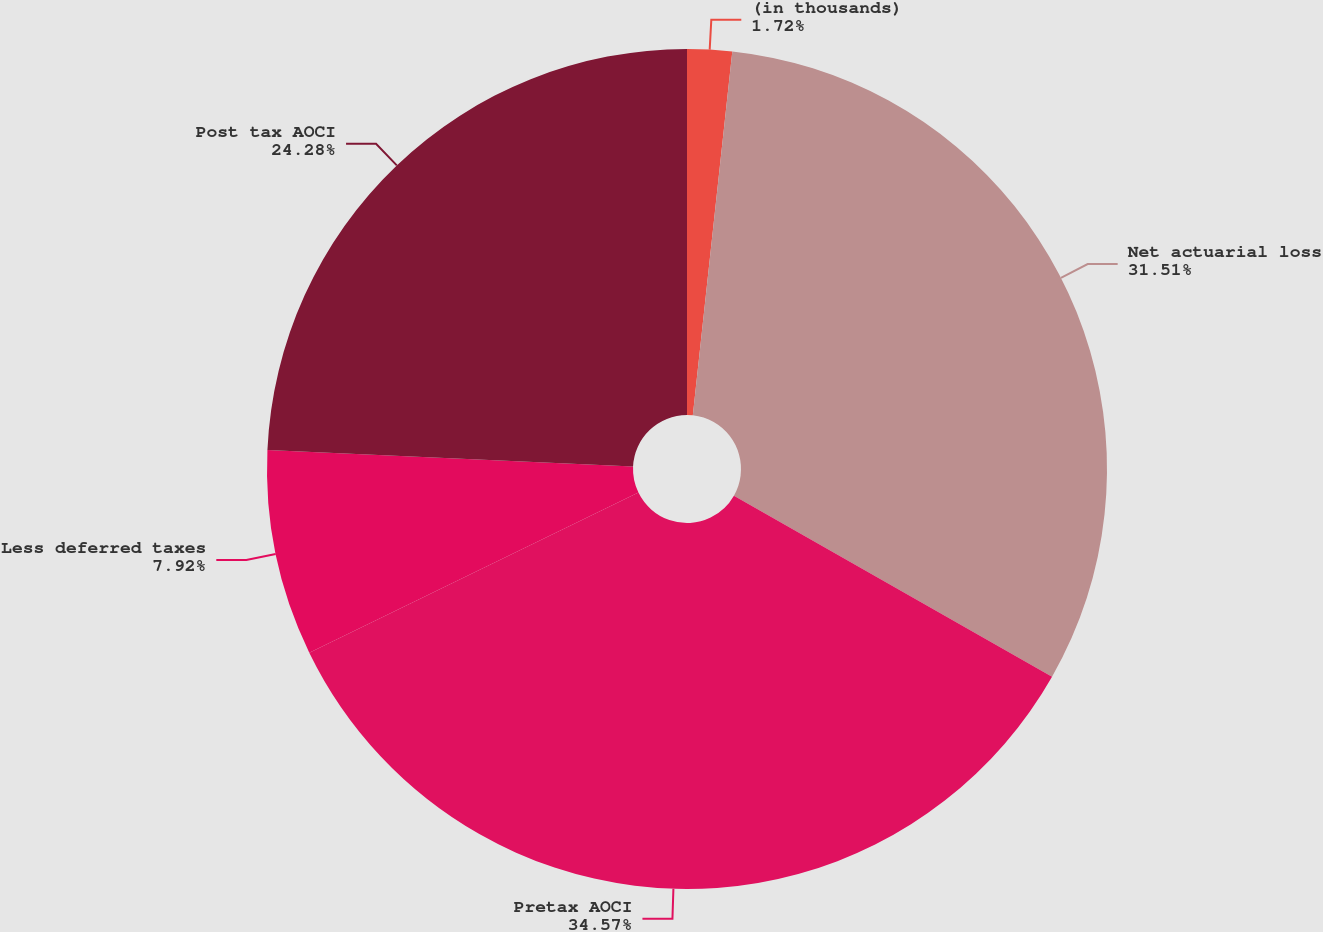Convert chart. <chart><loc_0><loc_0><loc_500><loc_500><pie_chart><fcel>(in thousands)<fcel>Net actuarial loss<fcel>Pretax AOCI<fcel>Less deferred taxes<fcel>Post tax AOCI<nl><fcel>1.72%<fcel>31.51%<fcel>34.56%<fcel>7.92%<fcel>24.28%<nl></chart> 